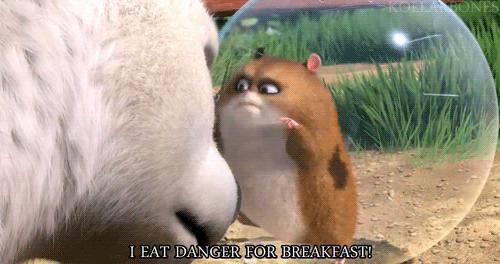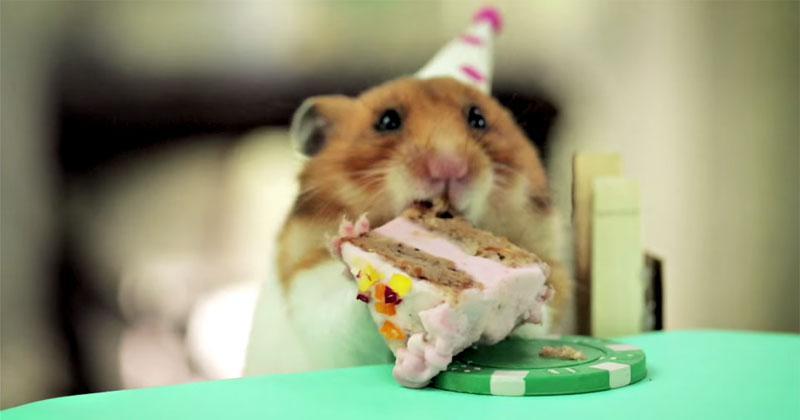The first image is the image on the left, the second image is the image on the right. For the images displayed, is the sentence "Two hamsters have something green in their mouths." factually correct? Answer yes or no. No. The first image is the image on the left, the second image is the image on the right. For the images displayed, is the sentence "One image shows two guinea pigs eating side by side." factually correct? Answer yes or no. No. 